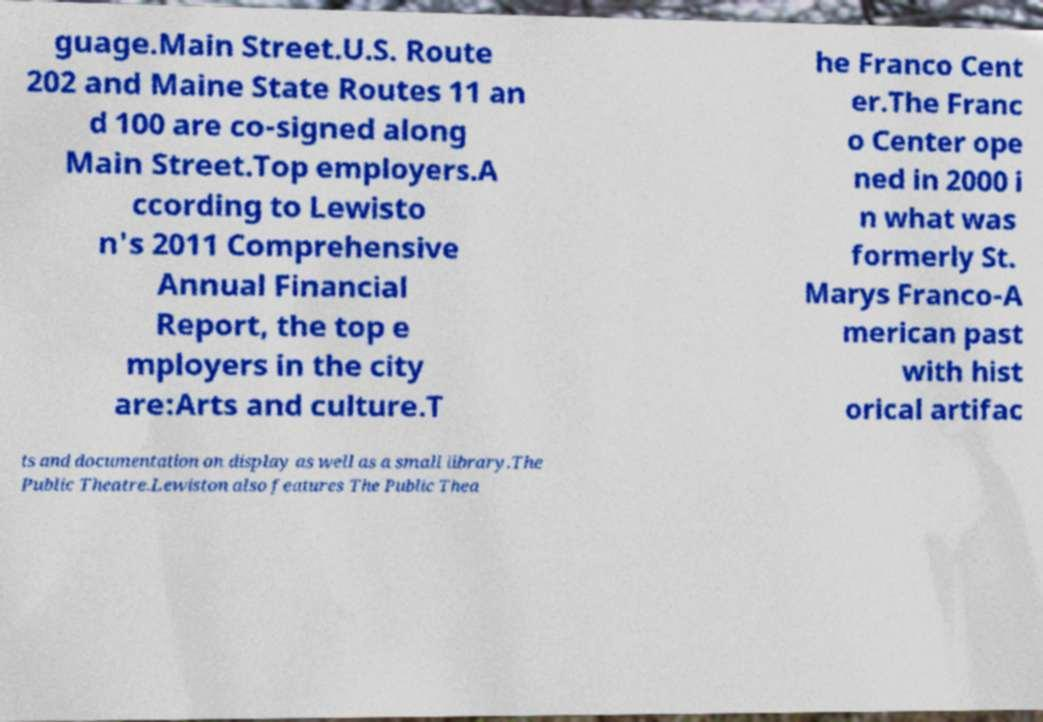For documentation purposes, I need the text within this image transcribed. Could you provide that? guage.Main Street.U.S. Route 202 and Maine State Routes 11 an d 100 are co-signed along Main Street.Top employers.A ccording to Lewisto n's 2011 Comprehensive Annual Financial Report, the top e mployers in the city are:Arts and culture.T he Franco Cent er.The Franc o Center ope ned in 2000 i n what was formerly St. Marys Franco-A merican past with hist orical artifac ts and documentation on display as well as a small library.The Public Theatre.Lewiston also features The Public Thea 